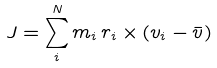<formula> <loc_0><loc_0><loc_500><loc_500>J = \sum _ { i } ^ { N } m _ { i } \, r _ { i } \times ( v _ { i } - \bar { v } )</formula> 